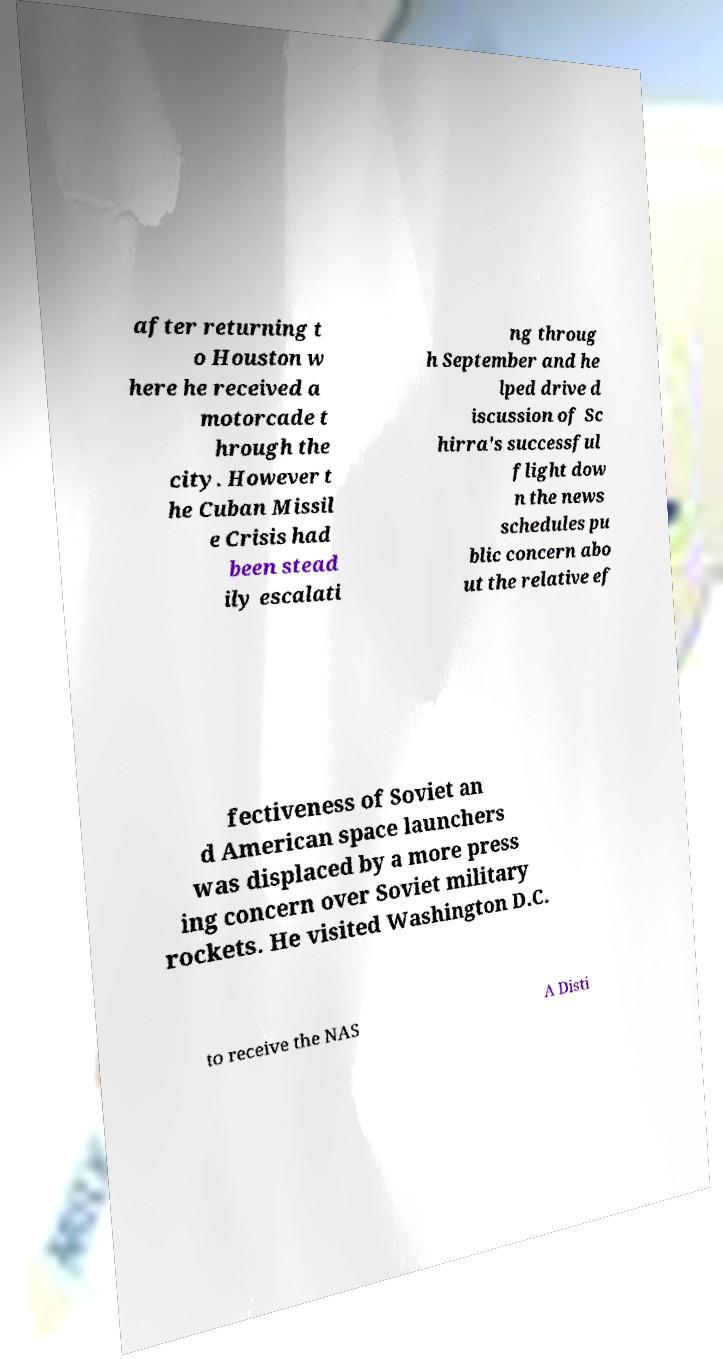Please identify and transcribe the text found in this image. after returning t o Houston w here he received a motorcade t hrough the city. However t he Cuban Missil e Crisis had been stead ily escalati ng throug h September and he lped drive d iscussion of Sc hirra's successful flight dow n the news schedules pu blic concern abo ut the relative ef fectiveness of Soviet an d American space launchers was displaced by a more press ing concern over Soviet military rockets. He visited Washington D.C. to receive the NAS A Disti 